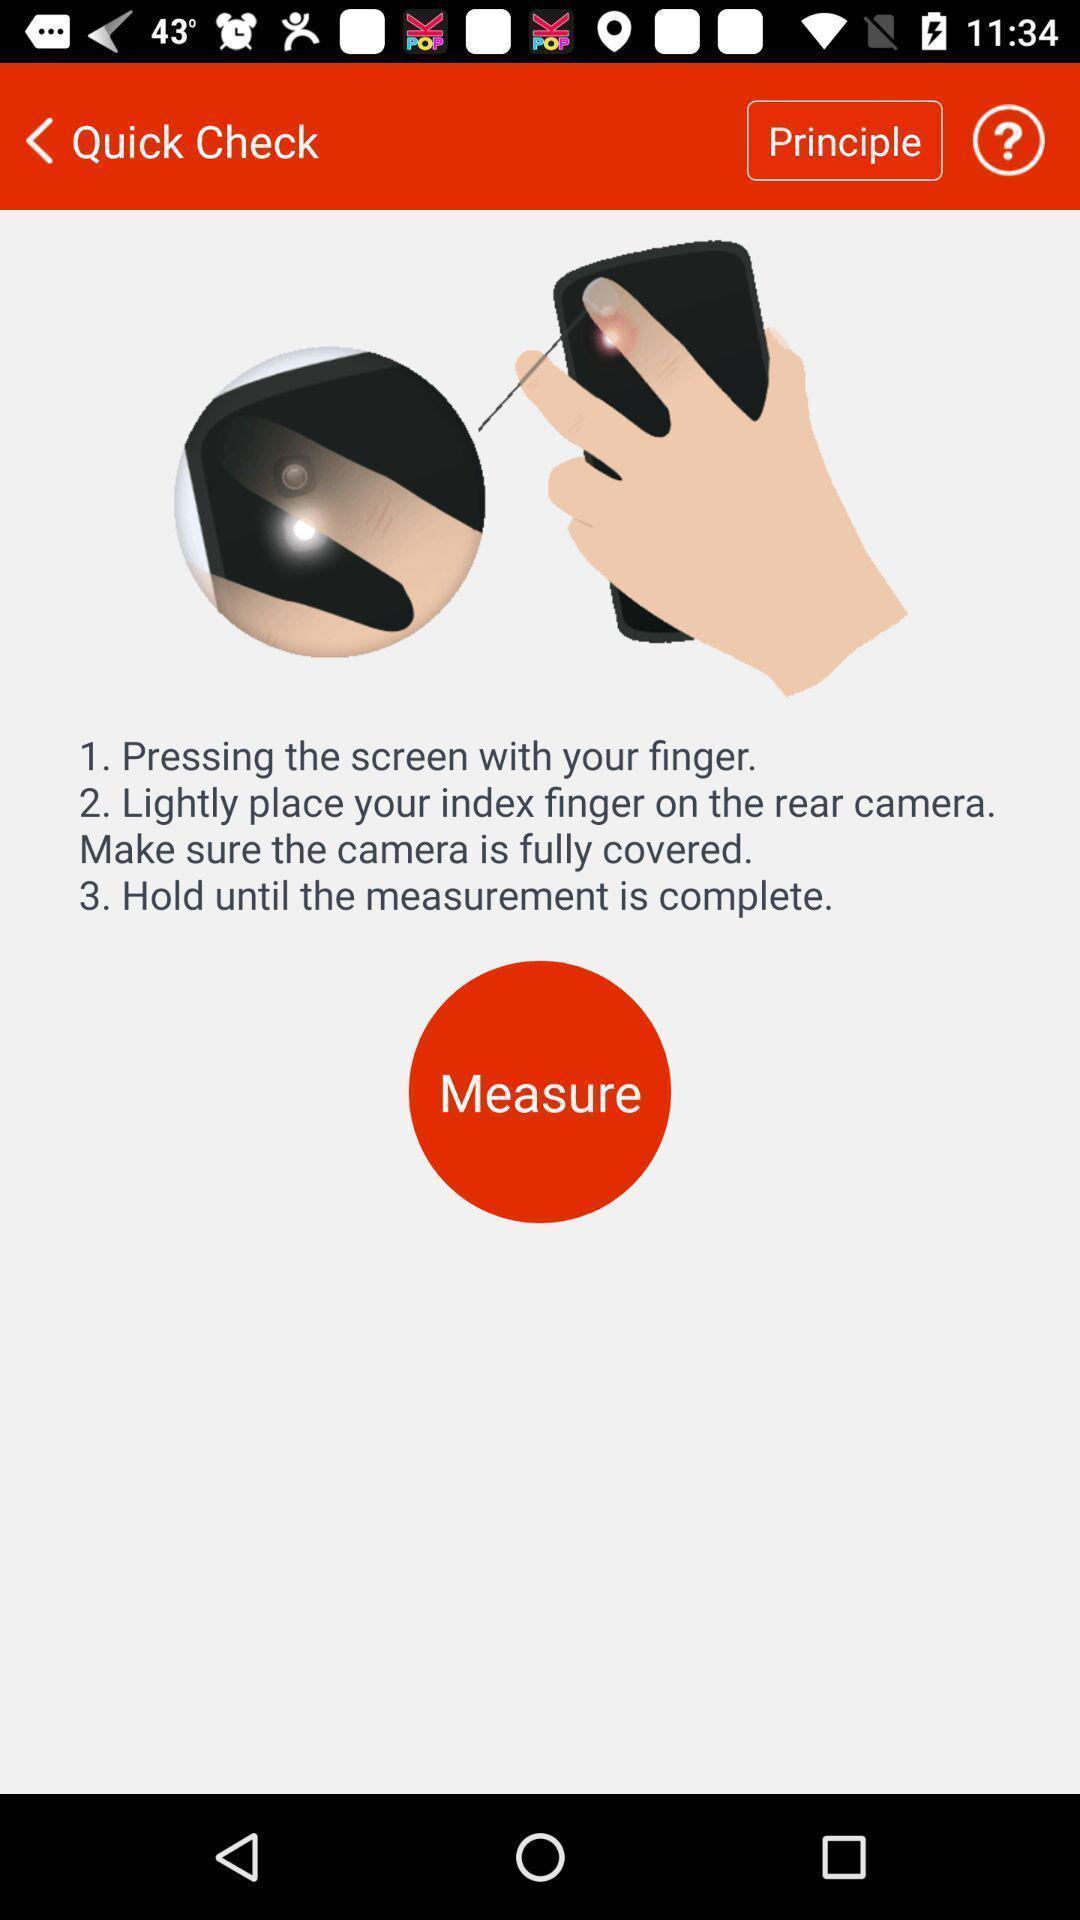Give me a narrative description of this picture. Screen displaying the instruction to operate device. 